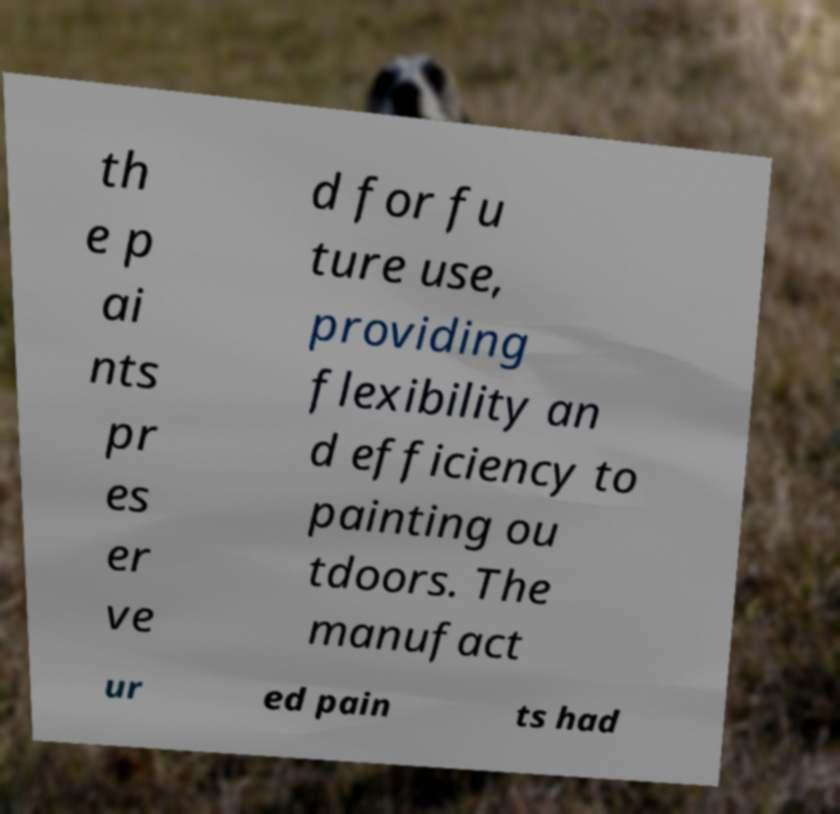Could you extract and type out the text from this image? th e p ai nts pr es er ve d for fu ture use, providing flexibility an d efficiency to painting ou tdoors. The manufact ur ed pain ts had 